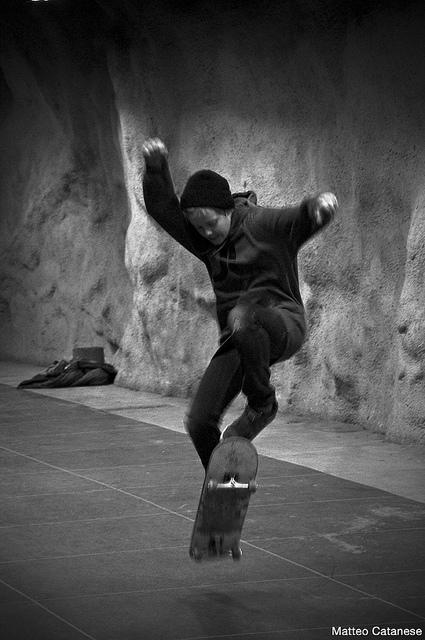What is the boy wearing on his head? beanie 